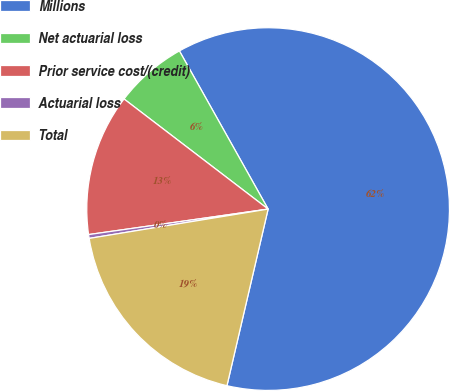Convert chart to OTSL. <chart><loc_0><loc_0><loc_500><loc_500><pie_chart><fcel>Millions<fcel>Net actuarial loss<fcel>Prior service cost/(credit)<fcel>Actuarial loss<fcel>Total<nl><fcel>61.78%<fcel>6.48%<fcel>12.63%<fcel>0.34%<fcel>18.77%<nl></chart> 